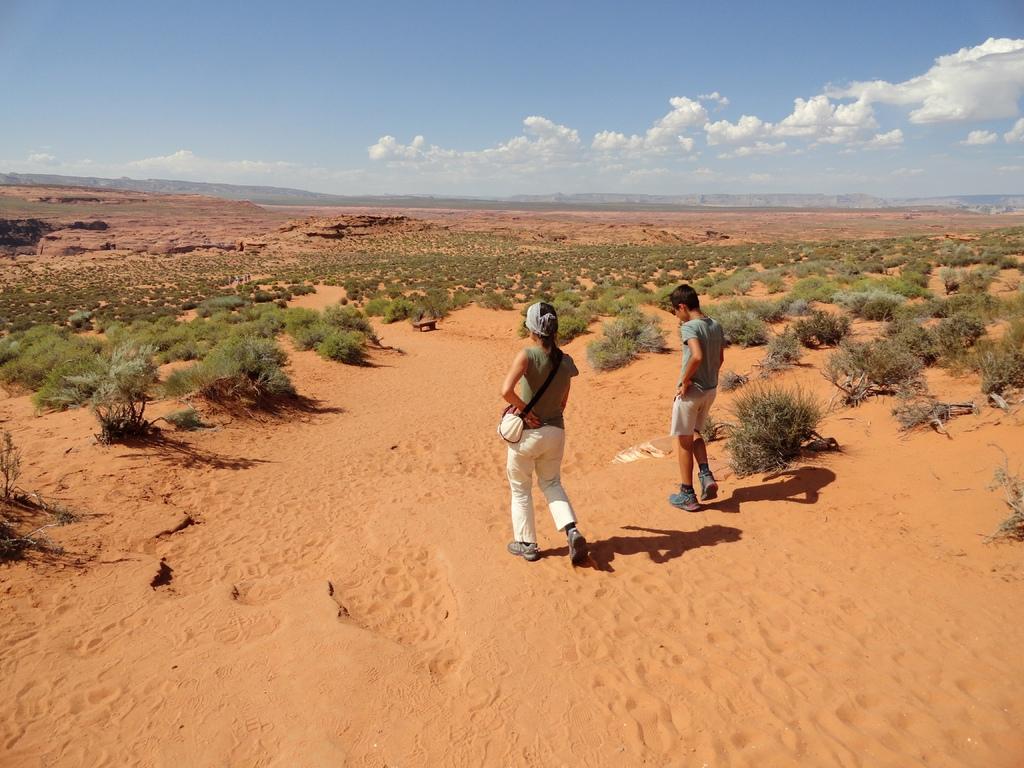How would you summarize this image in a sentence or two? In the middle 2 persons are walking on the sand, they wore t-shirts. There are trees in the sand, at the top it is the sky. 